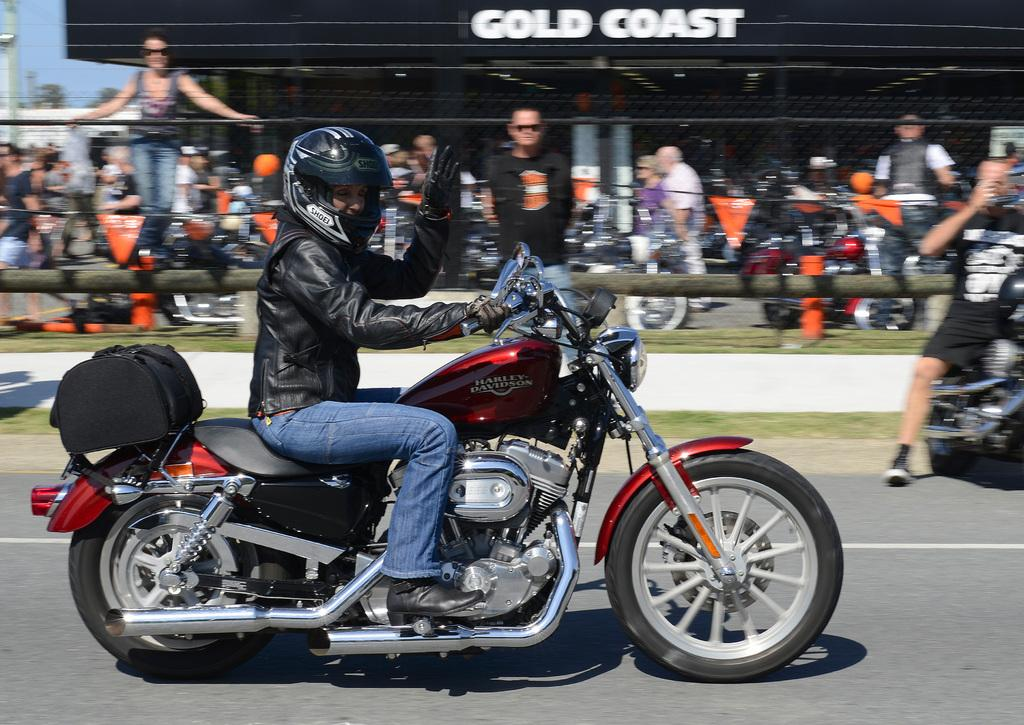What is the main subject of the image? The main subject of the image is a person driving a motorbike. What type of clothing is the person wearing? The person is wearing a jacket and blue jeans. What safety gear is the person wearing? The person is wearing a helmet. What can be seen in the background of the image? There are people standing, the sky, and a building visible in the background of the image. How many pens can be seen in the image? There are no pens present in the image. What type of sack is the person carrying on the motorbike? There is no sack visible in the image; the person is only wearing a jacket, blue jeans, and a helmet. 